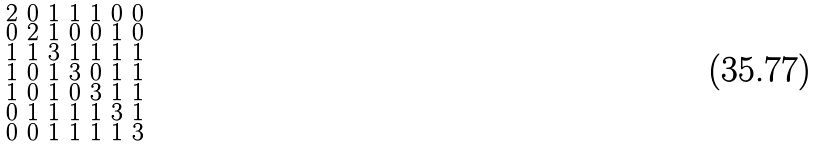<formula> <loc_0><loc_0><loc_500><loc_500>\begin{smallmatrix} 2 & 0 & 1 & 1 & 1 & 0 & 0 \\ 0 & 2 & 1 & 0 & 0 & 1 & 0 \\ 1 & 1 & 3 & 1 & 1 & 1 & 1 \\ 1 & 0 & 1 & 3 & 0 & 1 & 1 \\ 1 & 0 & 1 & 0 & 3 & 1 & 1 \\ 0 & 1 & 1 & 1 & 1 & 3 & 1 \\ 0 & 0 & 1 & 1 & 1 & 1 & 3 \end{smallmatrix}</formula> 